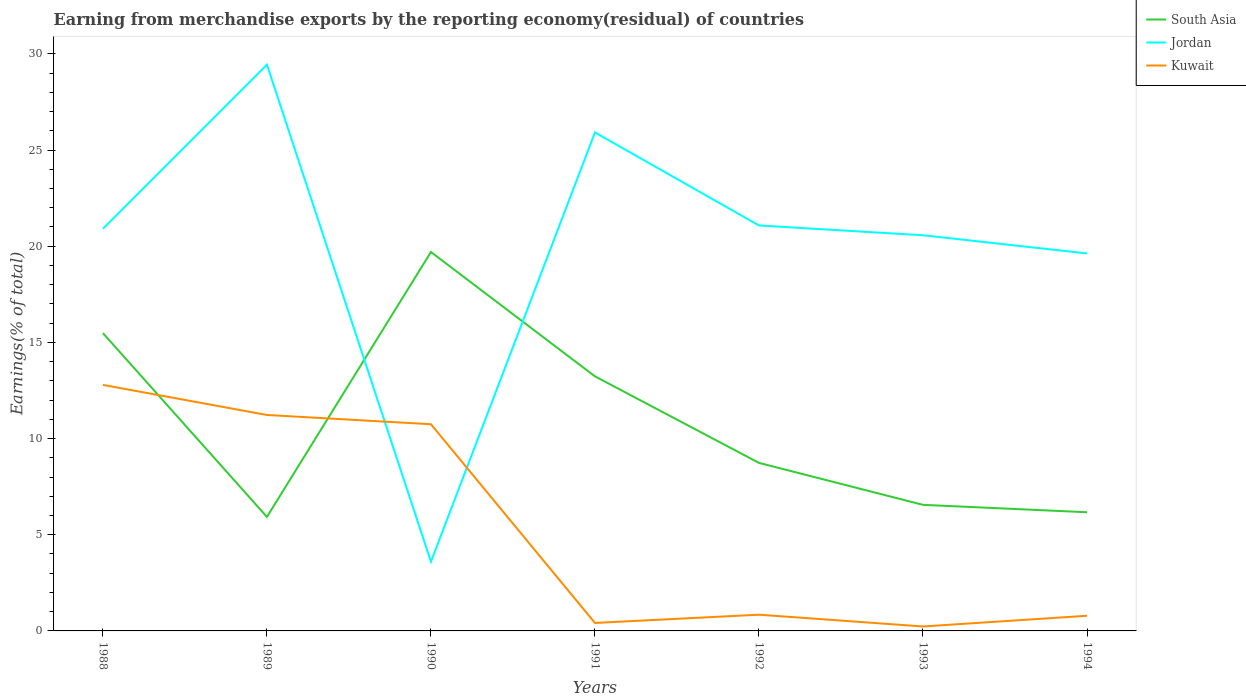How many different coloured lines are there?
Ensure brevity in your answer.  3. Is the number of lines equal to the number of legend labels?
Give a very brief answer. Yes. Across all years, what is the maximum percentage of amount earned from merchandise exports in Jordan?
Keep it short and to the point. 3.6. In which year was the percentage of amount earned from merchandise exports in South Asia maximum?
Provide a succinct answer. 1989. What is the total percentage of amount earned from merchandise exports in Jordan in the graph?
Your answer should be very brief. 5.35. What is the difference between the highest and the second highest percentage of amount earned from merchandise exports in Kuwait?
Give a very brief answer. 12.56. What is the difference between the highest and the lowest percentage of amount earned from merchandise exports in South Asia?
Your response must be concise. 3. Is the percentage of amount earned from merchandise exports in South Asia strictly greater than the percentage of amount earned from merchandise exports in Kuwait over the years?
Provide a succinct answer. No. How many years are there in the graph?
Make the answer very short. 7. What is the difference between two consecutive major ticks on the Y-axis?
Keep it short and to the point. 5. Does the graph contain grids?
Offer a very short reply. No. How many legend labels are there?
Your answer should be compact. 3. What is the title of the graph?
Give a very brief answer. Earning from merchandise exports by the reporting economy(residual) of countries. What is the label or title of the X-axis?
Offer a terse response. Years. What is the label or title of the Y-axis?
Provide a succinct answer. Earnings(% of total). What is the Earnings(% of total) in South Asia in 1988?
Offer a very short reply. 15.48. What is the Earnings(% of total) of Jordan in 1988?
Ensure brevity in your answer.  20.91. What is the Earnings(% of total) in Kuwait in 1988?
Your answer should be compact. 12.79. What is the Earnings(% of total) in South Asia in 1989?
Offer a terse response. 5.93. What is the Earnings(% of total) of Jordan in 1989?
Offer a terse response. 29.44. What is the Earnings(% of total) in Kuwait in 1989?
Offer a terse response. 11.23. What is the Earnings(% of total) of South Asia in 1990?
Provide a short and direct response. 19.7. What is the Earnings(% of total) of Jordan in 1990?
Provide a succinct answer. 3.6. What is the Earnings(% of total) in Kuwait in 1990?
Make the answer very short. 10.75. What is the Earnings(% of total) of South Asia in 1991?
Offer a terse response. 13.23. What is the Earnings(% of total) in Jordan in 1991?
Provide a short and direct response. 25.91. What is the Earnings(% of total) of Kuwait in 1991?
Give a very brief answer. 0.41. What is the Earnings(% of total) in South Asia in 1992?
Keep it short and to the point. 8.74. What is the Earnings(% of total) in Jordan in 1992?
Your answer should be very brief. 21.08. What is the Earnings(% of total) of Kuwait in 1992?
Your answer should be compact. 0.84. What is the Earnings(% of total) in South Asia in 1993?
Your answer should be very brief. 6.55. What is the Earnings(% of total) in Jordan in 1993?
Offer a very short reply. 20.57. What is the Earnings(% of total) of Kuwait in 1993?
Offer a very short reply. 0.23. What is the Earnings(% of total) of South Asia in 1994?
Your response must be concise. 6.17. What is the Earnings(% of total) in Jordan in 1994?
Provide a short and direct response. 19.62. What is the Earnings(% of total) in Kuwait in 1994?
Give a very brief answer. 0.79. Across all years, what is the maximum Earnings(% of total) of South Asia?
Your answer should be very brief. 19.7. Across all years, what is the maximum Earnings(% of total) in Jordan?
Your response must be concise. 29.44. Across all years, what is the maximum Earnings(% of total) in Kuwait?
Keep it short and to the point. 12.79. Across all years, what is the minimum Earnings(% of total) in South Asia?
Keep it short and to the point. 5.93. Across all years, what is the minimum Earnings(% of total) of Jordan?
Ensure brevity in your answer.  3.6. Across all years, what is the minimum Earnings(% of total) of Kuwait?
Give a very brief answer. 0.23. What is the total Earnings(% of total) of South Asia in the graph?
Your answer should be compact. 75.8. What is the total Earnings(% of total) of Jordan in the graph?
Give a very brief answer. 141.13. What is the total Earnings(% of total) in Kuwait in the graph?
Make the answer very short. 37.04. What is the difference between the Earnings(% of total) of South Asia in 1988 and that in 1989?
Make the answer very short. 9.56. What is the difference between the Earnings(% of total) in Jordan in 1988 and that in 1989?
Your response must be concise. -8.53. What is the difference between the Earnings(% of total) of Kuwait in 1988 and that in 1989?
Ensure brevity in your answer.  1.56. What is the difference between the Earnings(% of total) in South Asia in 1988 and that in 1990?
Keep it short and to the point. -4.21. What is the difference between the Earnings(% of total) of Jordan in 1988 and that in 1990?
Provide a succinct answer. 17.31. What is the difference between the Earnings(% of total) of Kuwait in 1988 and that in 1990?
Offer a terse response. 2.04. What is the difference between the Earnings(% of total) in South Asia in 1988 and that in 1991?
Make the answer very short. 2.25. What is the difference between the Earnings(% of total) of Jordan in 1988 and that in 1991?
Make the answer very short. -5.01. What is the difference between the Earnings(% of total) of Kuwait in 1988 and that in 1991?
Offer a terse response. 12.38. What is the difference between the Earnings(% of total) of South Asia in 1988 and that in 1992?
Your response must be concise. 6.75. What is the difference between the Earnings(% of total) of Jordan in 1988 and that in 1992?
Your answer should be compact. -0.17. What is the difference between the Earnings(% of total) of Kuwait in 1988 and that in 1992?
Ensure brevity in your answer.  11.95. What is the difference between the Earnings(% of total) of South Asia in 1988 and that in 1993?
Offer a terse response. 8.93. What is the difference between the Earnings(% of total) of Jordan in 1988 and that in 1993?
Provide a succinct answer. 0.34. What is the difference between the Earnings(% of total) of Kuwait in 1988 and that in 1993?
Your response must be concise. 12.56. What is the difference between the Earnings(% of total) of South Asia in 1988 and that in 1994?
Make the answer very short. 9.31. What is the difference between the Earnings(% of total) of Jordan in 1988 and that in 1994?
Provide a succinct answer. 1.28. What is the difference between the Earnings(% of total) in Kuwait in 1988 and that in 1994?
Offer a very short reply. 12. What is the difference between the Earnings(% of total) of South Asia in 1989 and that in 1990?
Ensure brevity in your answer.  -13.77. What is the difference between the Earnings(% of total) in Jordan in 1989 and that in 1990?
Your answer should be compact. 25.84. What is the difference between the Earnings(% of total) of Kuwait in 1989 and that in 1990?
Ensure brevity in your answer.  0.48. What is the difference between the Earnings(% of total) in South Asia in 1989 and that in 1991?
Give a very brief answer. -7.31. What is the difference between the Earnings(% of total) of Jordan in 1989 and that in 1991?
Your response must be concise. 3.52. What is the difference between the Earnings(% of total) in Kuwait in 1989 and that in 1991?
Give a very brief answer. 10.81. What is the difference between the Earnings(% of total) in South Asia in 1989 and that in 1992?
Your answer should be compact. -2.81. What is the difference between the Earnings(% of total) in Jordan in 1989 and that in 1992?
Your response must be concise. 8.36. What is the difference between the Earnings(% of total) of Kuwait in 1989 and that in 1992?
Your answer should be very brief. 10.38. What is the difference between the Earnings(% of total) in South Asia in 1989 and that in 1993?
Your answer should be very brief. -0.63. What is the difference between the Earnings(% of total) in Jordan in 1989 and that in 1993?
Your answer should be very brief. 8.87. What is the difference between the Earnings(% of total) in Kuwait in 1989 and that in 1993?
Ensure brevity in your answer.  10.99. What is the difference between the Earnings(% of total) of South Asia in 1989 and that in 1994?
Your answer should be compact. -0.24. What is the difference between the Earnings(% of total) of Jordan in 1989 and that in 1994?
Provide a short and direct response. 9.81. What is the difference between the Earnings(% of total) of Kuwait in 1989 and that in 1994?
Make the answer very short. 10.44. What is the difference between the Earnings(% of total) in South Asia in 1990 and that in 1991?
Provide a short and direct response. 6.46. What is the difference between the Earnings(% of total) of Jordan in 1990 and that in 1991?
Ensure brevity in your answer.  -22.32. What is the difference between the Earnings(% of total) in Kuwait in 1990 and that in 1991?
Provide a succinct answer. 10.33. What is the difference between the Earnings(% of total) in South Asia in 1990 and that in 1992?
Your answer should be very brief. 10.96. What is the difference between the Earnings(% of total) of Jordan in 1990 and that in 1992?
Your answer should be very brief. -17.48. What is the difference between the Earnings(% of total) of Kuwait in 1990 and that in 1992?
Your answer should be very brief. 9.9. What is the difference between the Earnings(% of total) of South Asia in 1990 and that in 1993?
Give a very brief answer. 13.14. What is the difference between the Earnings(% of total) in Jordan in 1990 and that in 1993?
Offer a very short reply. -16.97. What is the difference between the Earnings(% of total) of Kuwait in 1990 and that in 1993?
Your answer should be compact. 10.51. What is the difference between the Earnings(% of total) in South Asia in 1990 and that in 1994?
Provide a succinct answer. 13.53. What is the difference between the Earnings(% of total) in Jordan in 1990 and that in 1994?
Make the answer very short. -16.02. What is the difference between the Earnings(% of total) in Kuwait in 1990 and that in 1994?
Your response must be concise. 9.96. What is the difference between the Earnings(% of total) in South Asia in 1991 and that in 1992?
Your answer should be very brief. 4.5. What is the difference between the Earnings(% of total) in Jordan in 1991 and that in 1992?
Offer a terse response. 4.84. What is the difference between the Earnings(% of total) in Kuwait in 1991 and that in 1992?
Keep it short and to the point. -0.43. What is the difference between the Earnings(% of total) of South Asia in 1991 and that in 1993?
Make the answer very short. 6.68. What is the difference between the Earnings(% of total) in Jordan in 1991 and that in 1993?
Your answer should be very brief. 5.35. What is the difference between the Earnings(% of total) in Kuwait in 1991 and that in 1993?
Offer a very short reply. 0.18. What is the difference between the Earnings(% of total) in South Asia in 1991 and that in 1994?
Your answer should be compact. 7.06. What is the difference between the Earnings(% of total) of Jordan in 1991 and that in 1994?
Your response must be concise. 6.29. What is the difference between the Earnings(% of total) in Kuwait in 1991 and that in 1994?
Provide a short and direct response. -0.37. What is the difference between the Earnings(% of total) in South Asia in 1992 and that in 1993?
Provide a succinct answer. 2.18. What is the difference between the Earnings(% of total) of Jordan in 1992 and that in 1993?
Ensure brevity in your answer.  0.51. What is the difference between the Earnings(% of total) in Kuwait in 1992 and that in 1993?
Offer a terse response. 0.61. What is the difference between the Earnings(% of total) of South Asia in 1992 and that in 1994?
Make the answer very short. 2.57. What is the difference between the Earnings(% of total) of Jordan in 1992 and that in 1994?
Offer a very short reply. 1.46. What is the difference between the Earnings(% of total) of Kuwait in 1992 and that in 1994?
Ensure brevity in your answer.  0.06. What is the difference between the Earnings(% of total) of South Asia in 1993 and that in 1994?
Provide a succinct answer. 0.38. What is the difference between the Earnings(% of total) of Jordan in 1993 and that in 1994?
Your answer should be compact. 0.95. What is the difference between the Earnings(% of total) in Kuwait in 1993 and that in 1994?
Offer a very short reply. -0.56. What is the difference between the Earnings(% of total) in South Asia in 1988 and the Earnings(% of total) in Jordan in 1989?
Your response must be concise. -13.95. What is the difference between the Earnings(% of total) in South Asia in 1988 and the Earnings(% of total) in Kuwait in 1989?
Your answer should be compact. 4.26. What is the difference between the Earnings(% of total) of Jordan in 1988 and the Earnings(% of total) of Kuwait in 1989?
Offer a very short reply. 9.68. What is the difference between the Earnings(% of total) of South Asia in 1988 and the Earnings(% of total) of Jordan in 1990?
Provide a short and direct response. 11.89. What is the difference between the Earnings(% of total) of South Asia in 1988 and the Earnings(% of total) of Kuwait in 1990?
Your answer should be compact. 4.74. What is the difference between the Earnings(% of total) of Jordan in 1988 and the Earnings(% of total) of Kuwait in 1990?
Keep it short and to the point. 10.16. What is the difference between the Earnings(% of total) of South Asia in 1988 and the Earnings(% of total) of Jordan in 1991?
Keep it short and to the point. -10.43. What is the difference between the Earnings(% of total) of South Asia in 1988 and the Earnings(% of total) of Kuwait in 1991?
Give a very brief answer. 15.07. What is the difference between the Earnings(% of total) of Jordan in 1988 and the Earnings(% of total) of Kuwait in 1991?
Offer a terse response. 20.49. What is the difference between the Earnings(% of total) of South Asia in 1988 and the Earnings(% of total) of Jordan in 1992?
Give a very brief answer. -5.59. What is the difference between the Earnings(% of total) of South Asia in 1988 and the Earnings(% of total) of Kuwait in 1992?
Ensure brevity in your answer.  14.64. What is the difference between the Earnings(% of total) in Jordan in 1988 and the Earnings(% of total) in Kuwait in 1992?
Provide a succinct answer. 20.06. What is the difference between the Earnings(% of total) in South Asia in 1988 and the Earnings(% of total) in Jordan in 1993?
Provide a short and direct response. -5.08. What is the difference between the Earnings(% of total) in South Asia in 1988 and the Earnings(% of total) in Kuwait in 1993?
Your response must be concise. 15.25. What is the difference between the Earnings(% of total) of Jordan in 1988 and the Earnings(% of total) of Kuwait in 1993?
Provide a succinct answer. 20.67. What is the difference between the Earnings(% of total) of South Asia in 1988 and the Earnings(% of total) of Jordan in 1994?
Provide a short and direct response. -4.14. What is the difference between the Earnings(% of total) of South Asia in 1988 and the Earnings(% of total) of Kuwait in 1994?
Make the answer very short. 14.7. What is the difference between the Earnings(% of total) of Jordan in 1988 and the Earnings(% of total) of Kuwait in 1994?
Offer a terse response. 20.12. What is the difference between the Earnings(% of total) of South Asia in 1989 and the Earnings(% of total) of Jordan in 1990?
Your answer should be very brief. 2.33. What is the difference between the Earnings(% of total) in South Asia in 1989 and the Earnings(% of total) in Kuwait in 1990?
Make the answer very short. -4.82. What is the difference between the Earnings(% of total) of Jordan in 1989 and the Earnings(% of total) of Kuwait in 1990?
Your response must be concise. 18.69. What is the difference between the Earnings(% of total) in South Asia in 1989 and the Earnings(% of total) in Jordan in 1991?
Offer a very short reply. -19.99. What is the difference between the Earnings(% of total) of South Asia in 1989 and the Earnings(% of total) of Kuwait in 1991?
Offer a terse response. 5.51. What is the difference between the Earnings(% of total) of Jordan in 1989 and the Earnings(% of total) of Kuwait in 1991?
Your answer should be compact. 29.02. What is the difference between the Earnings(% of total) of South Asia in 1989 and the Earnings(% of total) of Jordan in 1992?
Offer a very short reply. -15.15. What is the difference between the Earnings(% of total) in South Asia in 1989 and the Earnings(% of total) in Kuwait in 1992?
Make the answer very short. 5.08. What is the difference between the Earnings(% of total) of Jordan in 1989 and the Earnings(% of total) of Kuwait in 1992?
Ensure brevity in your answer.  28.59. What is the difference between the Earnings(% of total) of South Asia in 1989 and the Earnings(% of total) of Jordan in 1993?
Provide a succinct answer. -14.64. What is the difference between the Earnings(% of total) of South Asia in 1989 and the Earnings(% of total) of Kuwait in 1993?
Your answer should be very brief. 5.7. What is the difference between the Earnings(% of total) of Jordan in 1989 and the Earnings(% of total) of Kuwait in 1993?
Give a very brief answer. 29.21. What is the difference between the Earnings(% of total) of South Asia in 1989 and the Earnings(% of total) of Jordan in 1994?
Provide a succinct answer. -13.7. What is the difference between the Earnings(% of total) in South Asia in 1989 and the Earnings(% of total) in Kuwait in 1994?
Your response must be concise. 5.14. What is the difference between the Earnings(% of total) of Jordan in 1989 and the Earnings(% of total) of Kuwait in 1994?
Make the answer very short. 28.65. What is the difference between the Earnings(% of total) in South Asia in 1990 and the Earnings(% of total) in Jordan in 1991?
Provide a succinct answer. -6.22. What is the difference between the Earnings(% of total) of South Asia in 1990 and the Earnings(% of total) of Kuwait in 1991?
Provide a short and direct response. 19.28. What is the difference between the Earnings(% of total) in Jordan in 1990 and the Earnings(% of total) in Kuwait in 1991?
Your answer should be compact. 3.18. What is the difference between the Earnings(% of total) in South Asia in 1990 and the Earnings(% of total) in Jordan in 1992?
Offer a terse response. -1.38. What is the difference between the Earnings(% of total) in South Asia in 1990 and the Earnings(% of total) in Kuwait in 1992?
Offer a very short reply. 18.85. What is the difference between the Earnings(% of total) of Jordan in 1990 and the Earnings(% of total) of Kuwait in 1992?
Offer a terse response. 2.75. What is the difference between the Earnings(% of total) in South Asia in 1990 and the Earnings(% of total) in Jordan in 1993?
Keep it short and to the point. -0.87. What is the difference between the Earnings(% of total) of South Asia in 1990 and the Earnings(% of total) of Kuwait in 1993?
Keep it short and to the point. 19.47. What is the difference between the Earnings(% of total) of Jordan in 1990 and the Earnings(% of total) of Kuwait in 1993?
Provide a short and direct response. 3.37. What is the difference between the Earnings(% of total) in South Asia in 1990 and the Earnings(% of total) in Jordan in 1994?
Provide a succinct answer. 0.07. What is the difference between the Earnings(% of total) in South Asia in 1990 and the Earnings(% of total) in Kuwait in 1994?
Provide a succinct answer. 18.91. What is the difference between the Earnings(% of total) in Jordan in 1990 and the Earnings(% of total) in Kuwait in 1994?
Give a very brief answer. 2.81. What is the difference between the Earnings(% of total) in South Asia in 1991 and the Earnings(% of total) in Jordan in 1992?
Your answer should be compact. -7.84. What is the difference between the Earnings(% of total) of South Asia in 1991 and the Earnings(% of total) of Kuwait in 1992?
Offer a very short reply. 12.39. What is the difference between the Earnings(% of total) of Jordan in 1991 and the Earnings(% of total) of Kuwait in 1992?
Offer a terse response. 25.07. What is the difference between the Earnings(% of total) in South Asia in 1991 and the Earnings(% of total) in Jordan in 1993?
Ensure brevity in your answer.  -7.33. What is the difference between the Earnings(% of total) in South Asia in 1991 and the Earnings(% of total) in Kuwait in 1993?
Your answer should be very brief. 13. What is the difference between the Earnings(% of total) of Jordan in 1991 and the Earnings(% of total) of Kuwait in 1993?
Keep it short and to the point. 25.68. What is the difference between the Earnings(% of total) of South Asia in 1991 and the Earnings(% of total) of Jordan in 1994?
Your response must be concise. -6.39. What is the difference between the Earnings(% of total) of South Asia in 1991 and the Earnings(% of total) of Kuwait in 1994?
Your answer should be compact. 12.45. What is the difference between the Earnings(% of total) in Jordan in 1991 and the Earnings(% of total) in Kuwait in 1994?
Your response must be concise. 25.13. What is the difference between the Earnings(% of total) in South Asia in 1992 and the Earnings(% of total) in Jordan in 1993?
Your answer should be very brief. -11.83. What is the difference between the Earnings(% of total) of South Asia in 1992 and the Earnings(% of total) of Kuwait in 1993?
Offer a very short reply. 8.5. What is the difference between the Earnings(% of total) of Jordan in 1992 and the Earnings(% of total) of Kuwait in 1993?
Your response must be concise. 20.85. What is the difference between the Earnings(% of total) of South Asia in 1992 and the Earnings(% of total) of Jordan in 1994?
Offer a terse response. -10.89. What is the difference between the Earnings(% of total) of South Asia in 1992 and the Earnings(% of total) of Kuwait in 1994?
Keep it short and to the point. 7.95. What is the difference between the Earnings(% of total) in Jordan in 1992 and the Earnings(% of total) in Kuwait in 1994?
Provide a succinct answer. 20.29. What is the difference between the Earnings(% of total) in South Asia in 1993 and the Earnings(% of total) in Jordan in 1994?
Your answer should be compact. -13.07. What is the difference between the Earnings(% of total) in South Asia in 1993 and the Earnings(% of total) in Kuwait in 1994?
Provide a short and direct response. 5.77. What is the difference between the Earnings(% of total) in Jordan in 1993 and the Earnings(% of total) in Kuwait in 1994?
Offer a very short reply. 19.78. What is the average Earnings(% of total) in South Asia per year?
Your response must be concise. 10.83. What is the average Earnings(% of total) of Jordan per year?
Keep it short and to the point. 20.16. What is the average Earnings(% of total) in Kuwait per year?
Provide a succinct answer. 5.29. In the year 1988, what is the difference between the Earnings(% of total) of South Asia and Earnings(% of total) of Jordan?
Offer a very short reply. -5.42. In the year 1988, what is the difference between the Earnings(% of total) in South Asia and Earnings(% of total) in Kuwait?
Your answer should be very brief. 2.69. In the year 1988, what is the difference between the Earnings(% of total) of Jordan and Earnings(% of total) of Kuwait?
Your answer should be compact. 8.11. In the year 1989, what is the difference between the Earnings(% of total) in South Asia and Earnings(% of total) in Jordan?
Provide a short and direct response. -23.51. In the year 1989, what is the difference between the Earnings(% of total) in South Asia and Earnings(% of total) in Kuwait?
Make the answer very short. -5.3. In the year 1989, what is the difference between the Earnings(% of total) of Jordan and Earnings(% of total) of Kuwait?
Your answer should be compact. 18.21. In the year 1990, what is the difference between the Earnings(% of total) in South Asia and Earnings(% of total) in Jordan?
Your answer should be compact. 16.1. In the year 1990, what is the difference between the Earnings(% of total) of South Asia and Earnings(% of total) of Kuwait?
Give a very brief answer. 8.95. In the year 1990, what is the difference between the Earnings(% of total) of Jordan and Earnings(% of total) of Kuwait?
Your answer should be compact. -7.15. In the year 1991, what is the difference between the Earnings(% of total) of South Asia and Earnings(% of total) of Jordan?
Provide a succinct answer. -12.68. In the year 1991, what is the difference between the Earnings(% of total) of South Asia and Earnings(% of total) of Kuwait?
Ensure brevity in your answer.  12.82. In the year 1991, what is the difference between the Earnings(% of total) of Jordan and Earnings(% of total) of Kuwait?
Keep it short and to the point. 25.5. In the year 1992, what is the difference between the Earnings(% of total) of South Asia and Earnings(% of total) of Jordan?
Ensure brevity in your answer.  -12.34. In the year 1992, what is the difference between the Earnings(% of total) of South Asia and Earnings(% of total) of Kuwait?
Offer a very short reply. 7.89. In the year 1992, what is the difference between the Earnings(% of total) of Jordan and Earnings(% of total) of Kuwait?
Offer a terse response. 20.23. In the year 1993, what is the difference between the Earnings(% of total) in South Asia and Earnings(% of total) in Jordan?
Keep it short and to the point. -14.01. In the year 1993, what is the difference between the Earnings(% of total) in South Asia and Earnings(% of total) in Kuwait?
Provide a succinct answer. 6.32. In the year 1993, what is the difference between the Earnings(% of total) in Jordan and Earnings(% of total) in Kuwait?
Offer a terse response. 20.34. In the year 1994, what is the difference between the Earnings(% of total) in South Asia and Earnings(% of total) in Jordan?
Your answer should be very brief. -13.45. In the year 1994, what is the difference between the Earnings(% of total) in South Asia and Earnings(% of total) in Kuwait?
Keep it short and to the point. 5.38. In the year 1994, what is the difference between the Earnings(% of total) in Jordan and Earnings(% of total) in Kuwait?
Make the answer very short. 18.84. What is the ratio of the Earnings(% of total) of South Asia in 1988 to that in 1989?
Ensure brevity in your answer.  2.61. What is the ratio of the Earnings(% of total) in Jordan in 1988 to that in 1989?
Keep it short and to the point. 0.71. What is the ratio of the Earnings(% of total) in Kuwait in 1988 to that in 1989?
Offer a very short reply. 1.14. What is the ratio of the Earnings(% of total) in South Asia in 1988 to that in 1990?
Your answer should be compact. 0.79. What is the ratio of the Earnings(% of total) of Jordan in 1988 to that in 1990?
Ensure brevity in your answer.  5.81. What is the ratio of the Earnings(% of total) of Kuwait in 1988 to that in 1990?
Ensure brevity in your answer.  1.19. What is the ratio of the Earnings(% of total) in South Asia in 1988 to that in 1991?
Give a very brief answer. 1.17. What is the ratio of the Earnings(% of total) of Jordan in 1988 to that in 1991?
Your answer should be very brief. 0.81. What is the ratio of the Earnings(% of total) in Kuwait in 1988 to that in 1991?
Provide a short and direct response. 30.83. What is the ratio of the Earnings(% of total) in South Asia in 1988 to that in 1992?
Offer a terse response. 1.77. What is the ratio of the Earnings(% of total) of Kuwait in 1988 to that in 1992?
Your answer should be very brief. 15.16. What is the ratio of the Earnings(% of total) of South Asia in 1988 to that in 1993?
Your answer should be very brief. 2.36. What is the ratio of the Earnings(% of total) in Jordan in 1988 to that in 1993?
Offer a terse response. 1.02. What is the ratio of the Earnings(% of total) of Kuwait in 1988 to that in 1993?
Make the answer very short. 55.37. What is the ratio of the Earnings(% of total) in South Asia in 1988 to that in 1994?
Keep it short and to the point. 2.51. What is the ratio of the Earnings(% of total) in Jordan in 1988 to that in 1994?
Your answer should be very brief. 1.07. What is the ratio of the Earnings(% of total) in Kuwait in 1988 to that in 1994?
Ensure brevity in your answer.  16.23. What is the ratio of the Earnings(% of total) in South Asia in 1989 to that in 1990?
Make the answer very short. 0.3. What is the ratio of the Earnings(% of total) in Jordan in 1989 to that in 1990?
Offer a very short reply. 8.18. What is the ratio of the Earnings(% of total) of Kuwait in 1989 to that in 1990?
Provide a succinct answer. 1.04. What is the ratio of the Earnings(% of total) in South Asia in 1989 to that in 1991?
Offer a terse response. 0.45. What is the ratio of the Earnings(% of total) in Jordan in 1989 to that in 1991?
Give a very brief answer. 1.14. What is the ratio of the Earnings(% of total) of Kuwait in 1989 to that in 1991?
Keep it short and to the point. 27.06. What is the ratio of the Earnings(% of total) of South Asia in 1989 to that in 1992?
Make the answer very short. 0.68. What is the ratio of the Earnings(% of total) in Jordan in 1989 to that in 1992?
Offer a very short reply. 1.4. What is the ratio of the Earnings(% of total) of Kuwait in 1989 to that in 1992?
Your response must be concise. 13.3. What is the ratio of the Earnings(% of total) of South Asia in 1989 to that in 1993?
Keep it short and to the point. 0.9. What is the ratio of the Earnings(% of total) in Jordan in 1989 to that in 1993?
Make the answer very short. 1.43. What is the ratio of the Earnings(% of total) of Kuwait in 1989 to that in 1993?
Your answer should be compact. 48.6. What is the ratio of the Earnings(% of total) in South Asia in 1989 to that in 1994?
Keep it short and to the point. 0.96. What is the ratio of the Earnings(% of total) of Jordan in 1989 to that in 1994?
Give a very brief answer. 1.5. What is the ratio of the Earnings(% of total) of Kuwait in 1989 to that in 1994?
Provide a succinct answer. 14.25. What is the ratio of the Earnings(% of total) in South Asia in 1990 to that in 1991?
Offer a terse response. 1.49. What is the ratio of the Earnings(% of total) of Jordan in 1990 to that in 1991?
Ensure brevity in your answer.  0.14. What is the ratio of the Earnings(% of total) in Kuwait in 1990 to that in 1991?
Provide a succinct answer. 25.9. What is the ratio of the Earnings(% of total) of South Asia in 1990 to that in 1992?
Keep it short and to the point. 2.25. What is the ratio of the Earnings(% of total) of Jordan in 1990 to that in 1992?
Make the answer very short. 0.17. What is the ratio of the Earnings(% of total) in Kuwait in 1990 to that in 1992?
Give a very brief answer. 12.73. What is the ratio of the Earnings(% of total) in South Asia in 1990 to that in 1993?
Give a very brief answer. 3.01. What is the ratio of the Earnings(% of total) in Jordan in 1990 to that in 1993?
Ensure brevity in your answer.  0.17. What is the ratio of the Earnings(% of total) of Kuwait in 1990 to that in 1993?
Your answer should be very brief. 46.52. What is the ratio of the Earnings(% of total) of South Asia in 1990 to that in 1994?
Offer a very short reply. 3.19. What is the ratio of the Earnings(% of total) of Jordan in 1990 to that in 1994?
Make the answer very short. 0.18. What is the ratio of the Earnings(% of total) in Kuwait in 1990 to that in 1994?
Give a very brief answer. 13.64. What is the ratio of the Earnings(% of total) of South Asia in 1991 to that in 1992?
Keep it short and to the point. 1.51. What is the ratio of the Earnings(% of total) in Jordan in 1991 to that in 1992?
Keep it short and to the point. 1.23. What is the ratio of the Earnings(% of total) in Kuwait in 1991 to that in 1992?
Keep it short and to the point. 0.49. What is the ratio of the Earnings(% of total) of South Asia in 1991 to that in 1993?
Ensure brevity in your answer.  2.02. What is the ratio of the Earnings(% of total) in Jordan in 1991 to that in 1993?
Offer a very short reply. 1.26. What is the ratio of the Earnings(% of total) of Kuwait in 1991 to that in 1993?
Your answer should be compact. 1.8. What is the ratio of the Earnings(% of total) in South Asia in 1991 to that in 1994?
Offer a very short reply. 2.15. What is the ratio of the Earnings(% of total) in Jordan in 1991 to that in 1994?
Your response must be concise. 1.32. What is the ratio of the Earnings(% of total) in Kuwait in 1991 to that in 1994?
Ensure brevity in your answer.  0.53. What is the ratio of the Earnings(% of total) in South Asia in 1992 to that in 1993?
Offer a very short reply. 1.33. What is the ratio of the Earnings(% of total) in Jordan in 1992 to that in 1993?
Offer a very short reply. 1.02. What is the ratio of the Earnings(% of total) in Kuwait in 1992 to that in 1993?
Give a very brief answer. 3.65. What is the ratio of the Earnings(% of total) in South Asia in 1992 to that in 1994?
Give a very brief answer. 1.42. What is the ratio of the Earnings(% of total) in Jordan in 1992 to that in 1994?
Ensure brevity in your answer.  1.07. What is the ratio of the Earnings(% of total) in Kuwait in 1992 to that in 1994?
Provide a succinct answer. 1.07. What is the ratio of the Earnings(% of total) of South Asia in 1993 to that in 1994?
Offer a very short reply. 1.06. What is the ratio of the Earnings(% of total) in Jordan in 1993 to that in 1994?
Offer a terse response. 1.05. What is the ratio of the Earnings(% of total) in Kuwait in 1993 to that in 1994?
Your answer should be very brief. 0.29. What is the difference between the highest and the second highest Earnings(% of total) of South Asia?
Ensure brevity in your answer.  4.21. What is the difference between the highest and the second highest Earnings(% of total) in Jordan?
Your answer should be compact. 3.52. What is the difference between the highest and the second highest Earnings(% of total) in Kuwait?
Your response must be concise. 1.56. What is the difference between the highest and the lowest Earnings(% of total) in South Asia?
Your response must be concise. 13.77. What is the difference between the highest and the lowest Earnings(% of total) in Jordan?
Provide a short and direct response. 25.84. What is the difference between the highest and the lowest Earnings(% of total) in Kuwait?
Provide a short and direct response. 12.56. 